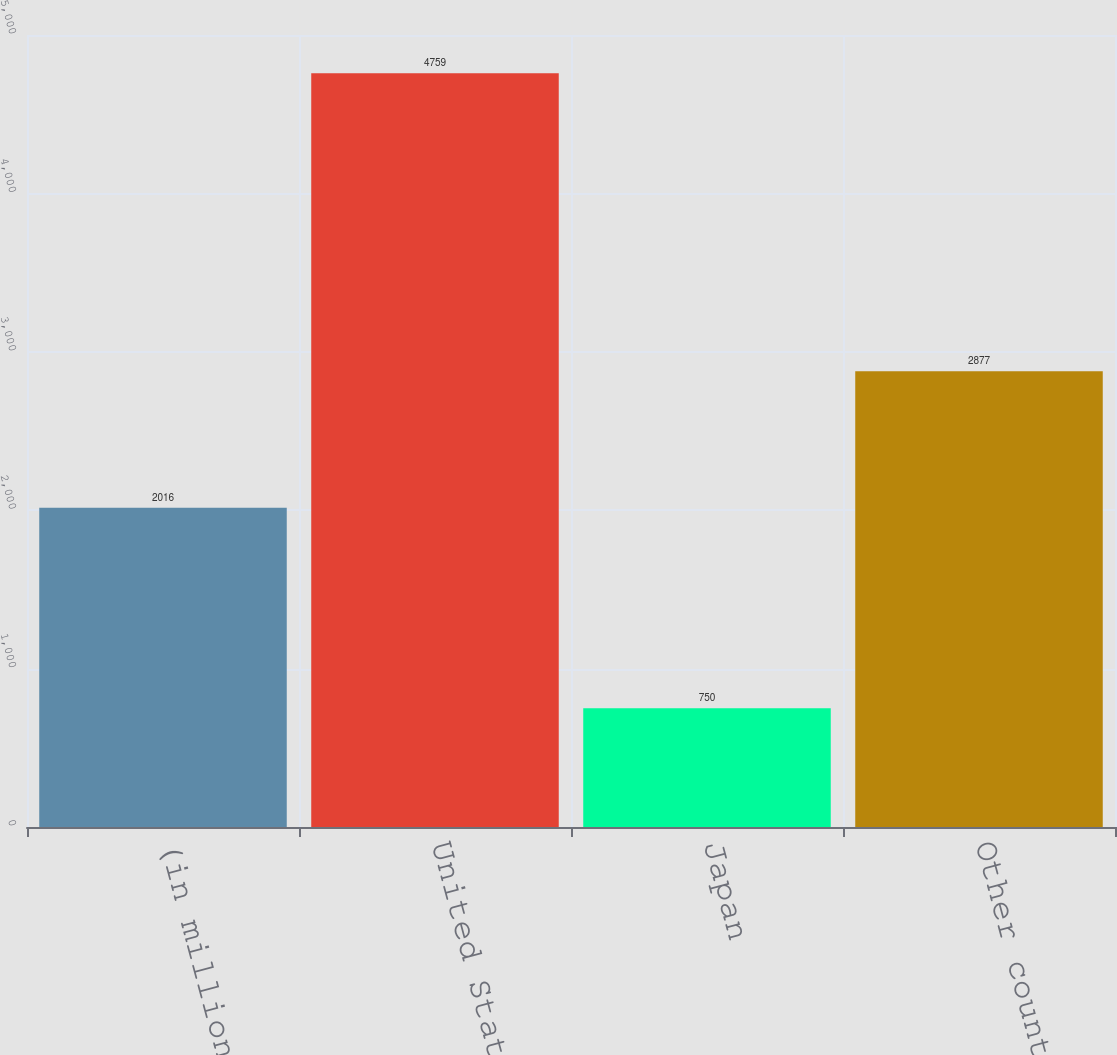<chart> <loc_0><loc_0><loc_500><loc_500><bar_chart><fcel>(in millions)<fcel>United States<fcel>Japan<fcel>Other countries<nl><fcel>2016<fcel>4759<fcel>750<fcel>2877<nl></chart> 